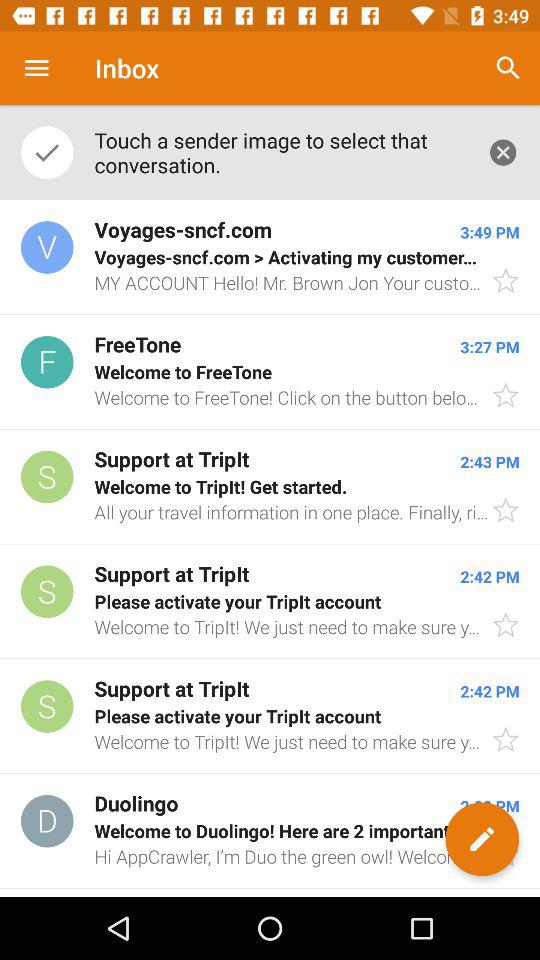At what time does the mail received from duolingo?
When the provided information is insufficient, respond with <no answer>. <no answer> 